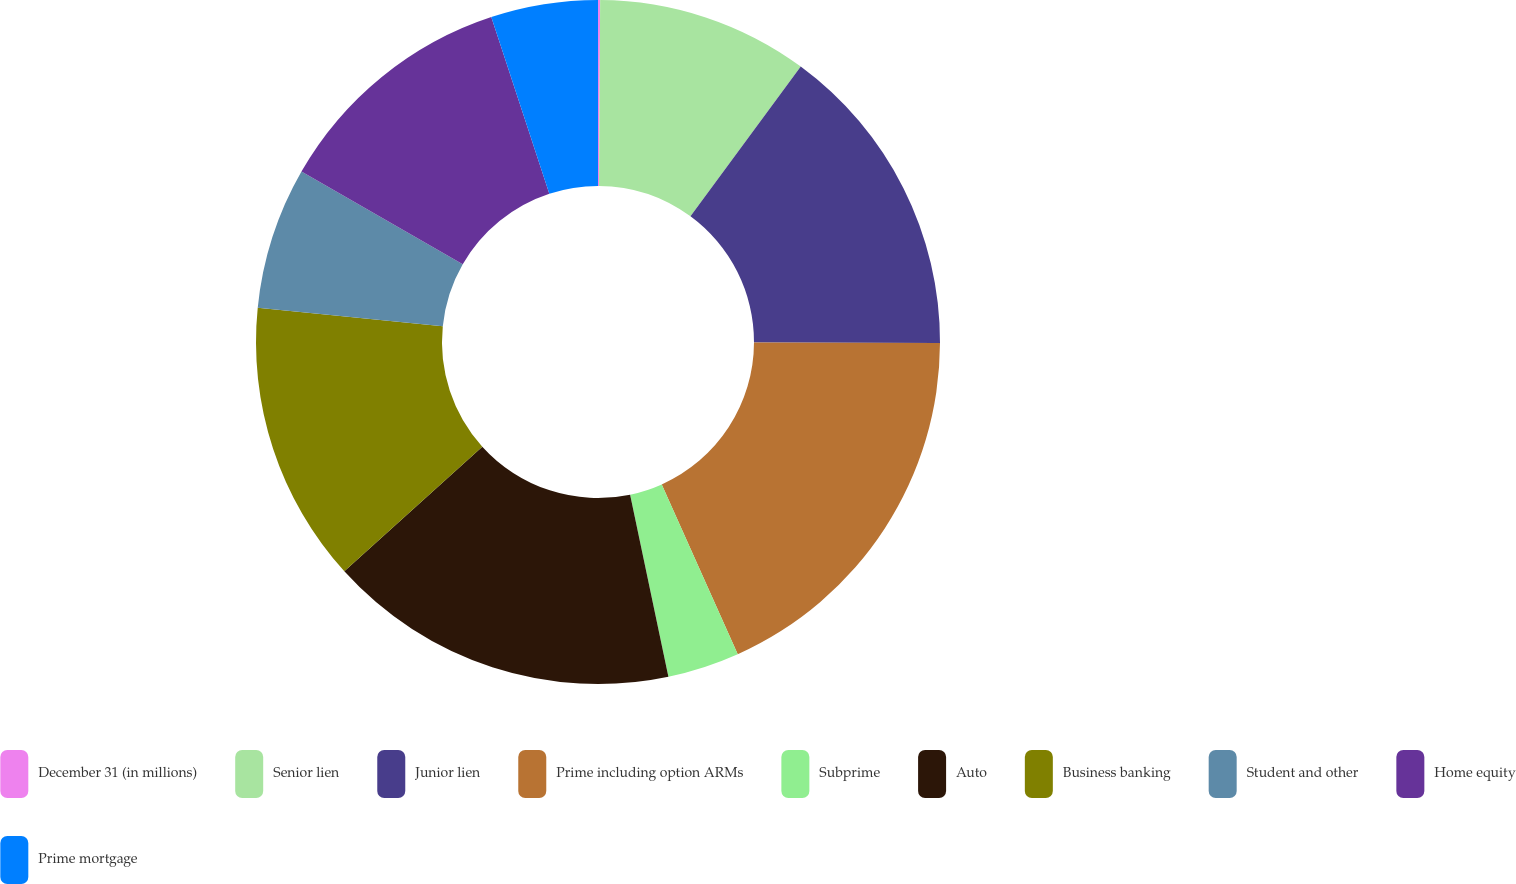Convert chart to OTSL. <chart><loc_0><loc_0><loc_500><loc_500><pie_chart><fcel>December 31 (in millions)<fcel>Senior lien<fcel>Junior lien<fcel>Prime including option ARMs<fcel>Subprime<fcel>Auto<fcel>Business banking<fcel>Student and other<fcel>Home equity<fcel>Prime mortgage<nl><fcel>0.1%<fcel>10.0%<fcel>14.95%<fcel>18.25%<fcel>3.4%<fcel>16.6%<fcel>13.3%<fcel>6.7%<fcel>11.65%<fcel>5.05%<nl></chart> 